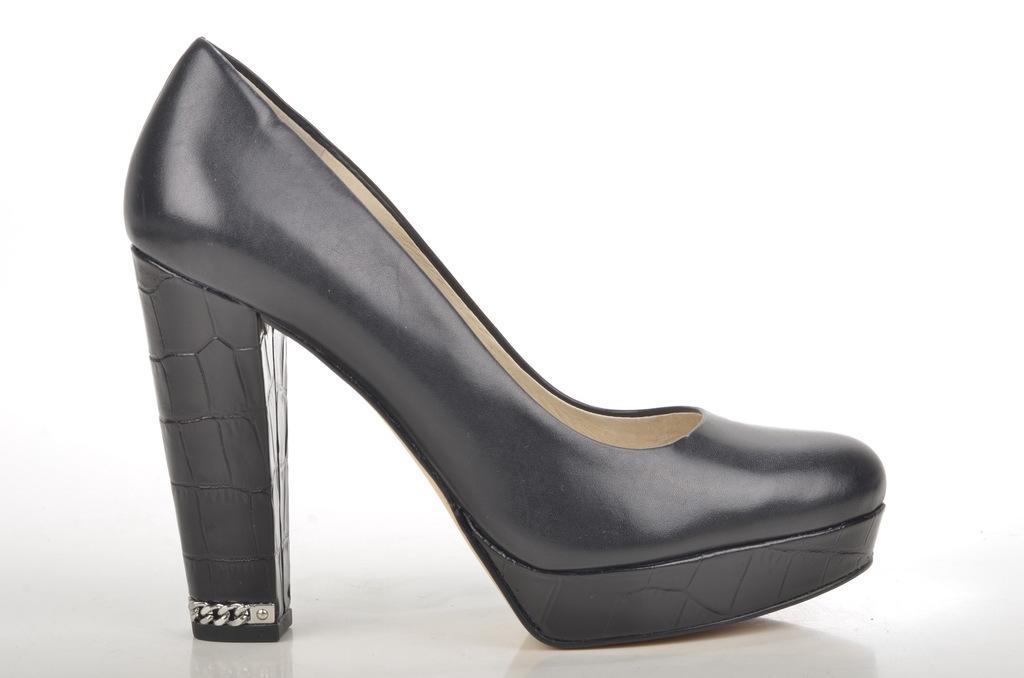In one or two sentences, can you explain what this image depicts? In this image we can see black color shoe. 